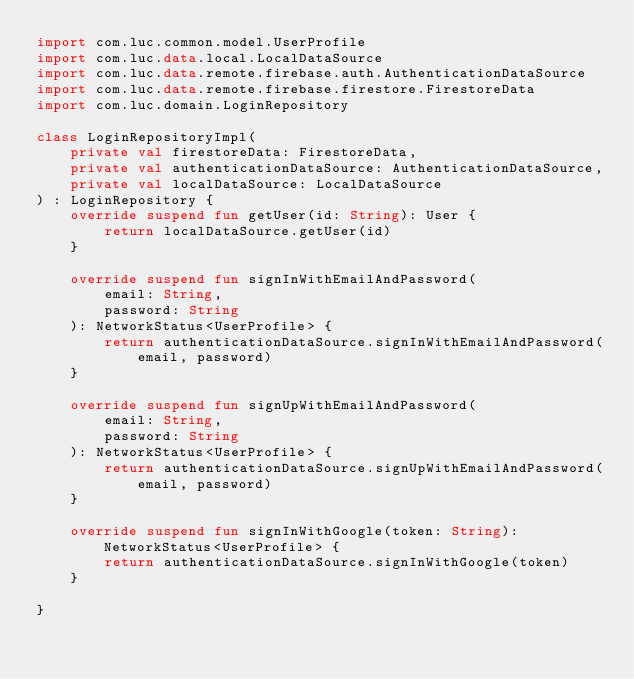<code> <loc_0><loc_0><loc_500><loc_500><_Kotlin_>import com.luc.common.model.UserProfile
import com.luc.data.local.LocalDataSource
import com.luc.data.remote.firebase.auth.AuthenticationDataSource
import com.luc.data.remote.firebase.firestore.FirestoreData
import com.luc.domain.LoginRepository

class LoginRepositoryImpl(
    private val firestoreData: FirestoreData,
    private val authenticationDataSource: AuthenticationDataSource,
    private val localDataSource: LocalDataSource
) : LoginRepository {
    override suspend fun getUser(id: String): User {
        return localDataSource.getUser(id)
    }

    override suspend fun signInWithEmailAndPassword(
        email: String,
        password: String
    ): NetworkStatus<UserProfile> {
        return authenticationDataSource.signInWithEmailAndPassword(email, password)
    }

    override suspend fun signUpWithEmailAndPassword(
        email: String,
        password: String
    ): NetworkStatus<UserProfile> {
        return authenticationDataSource.signUpWithEmailAndPassword(email, password)
    }

    override suspend fun signInWithGoogle(token: String): NetworkStatus<UserProfile> {
        return authenticationDataSource.signInWithGoogle(token)
    }

}</code> 